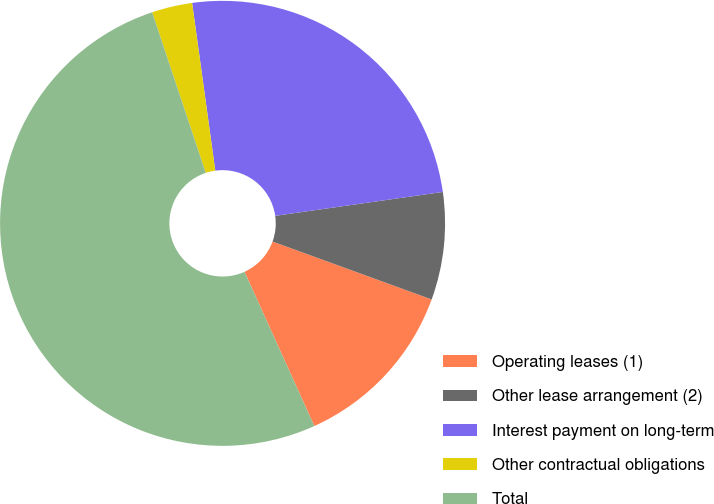<chart> <loc_0><loc_0><loc_500><loc_500><pie_chart><fcel>Operating leases (1)<fcel>Other lease arrangement (2)<fcel>Interest payment on long-term<fcel>Other contractual obligations<fcel>Total<nl><fcel>12.68%<fcel>7.81%<fcel>24.93%<fcel>2.94%<fcel>51.64%<nl></chart> 